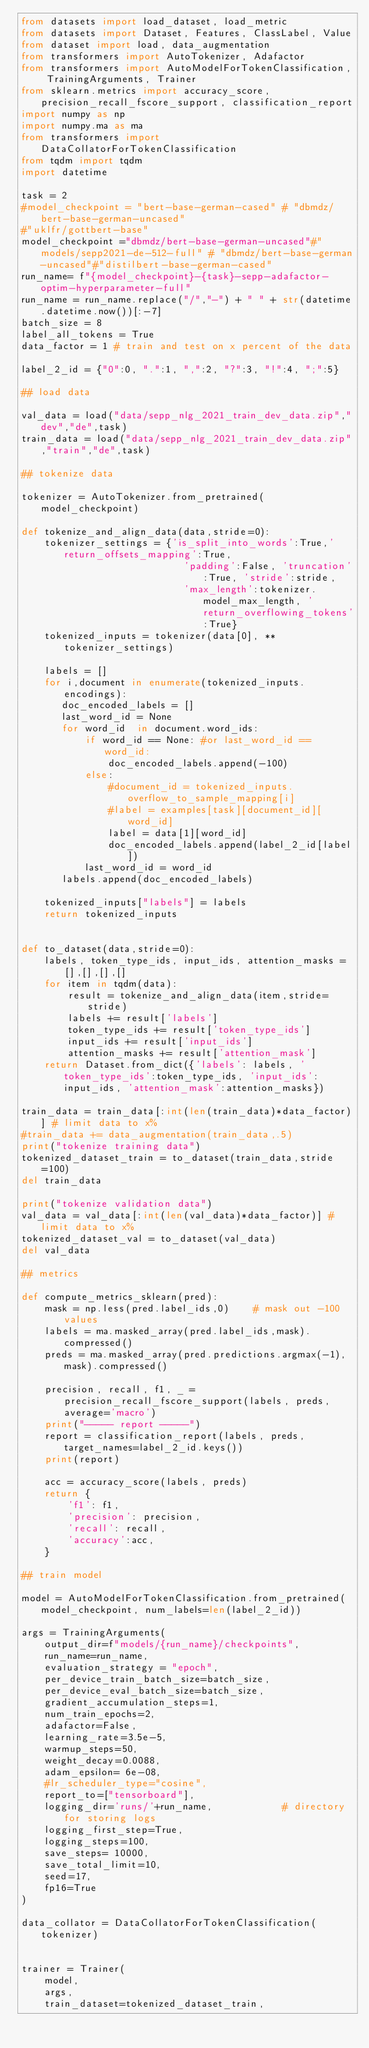<code> <loc_0><loc_0><loc_500><loc_500><_Python_>from datasets import load_dataset, load_metric
from datasets import Dataset, Features, ClassLabel, Value
from dataset import load, data_augmentation
from transformers import AutoTokenizer, Adafactor
from transformers import AutoModelForTokenClassification, TrainingArguments, Trainer
from sklearn.metrics import accuracy_score, precision_recall_fscore_support, classification_report
import numpy as np
import numpy.ma as ma
from transformers import DataCollatorForTokenClassification
from tqdm import tqdm
import datetime

task = 2 
#model_checkpoint = "bert-base-german-cased" # "dbmdz/bert-base-german-uncased"
#"uklfr/gottbert-base"
model_checkpoint ="dbmdz/bert-base-german-uncased"#"models/sepp2021-de-512-full" # "dbmdz/bert-base-german-uncased"#"distilbert-base-german-cased"
run_name= f"{model_checkpoint}-{task}-sepp-adafactor-optim-hyperparameter-full"
run_name = run_name.replace("/","-") + " " + str(datetime.datetime.now())[:-7]
batch_size = 8
label_all_tokens = True
data_factor = 1 # train and test on x percent of the data

label_2_id = {"0":0, ".":1, ",":2, "?":3, "!":4, ";":5}

## load data

val_data = load("data/sepp_nlg_2021_train_dev_data.zip","dev","de",task)
train_data = load("data/sepp_nlg_2021_train_dev_data.zip","train","de",task)

## tokenize data
    
tokenizer = AutoTokenizer.from_pretrained(model_checkpoint)

def tokenize_and_align_data(data,stride=0):
    tokenizer_settings = {'is_split_into_words':True,'return_offsets_mapping':True, 
                            'padding':False, 'truncation':True, 'stride':stride, 
                            'max_length':tokenizer.model_max_length, 'return_overflowing_tokens':True}
    tokenized_inputs = tokenizer(data[0], **tokenizer_settings)

    labels = []
    for i,document in enumerate(tokenized_inputs.encodings):
       doc_encoded_labels = []
       last_word_id = None
       for word_id  in document.word_ids:            
           if word_id == None: #or last_word_id == word_id:
               doc_encoded_labels.append(-100)        
           else:
               #document_id = tokenized_inputs.overflow_to_sample_mapping[i]
               #label = examples[task][document_id][word_id]
               label = data[1][word_id]
               doc_encoded_labels.append(label_2_id[label])
           last_word_id = word_id
       labels.append(doc_encoded_labels)
    
    tokenized_inputs["labels"] = labels    
    return tokenized_inputs


def to_dataset(data,stride=0):
    labels, token_type_ids, input_ids, attention_masks = [],[],[],[]
    for item in tqdm(data):
        result = tokenize_and_align_data(item,stride=stride)        
        labels += result['labels']
        token_type_ids += result['token_type_ids']
        input_ids += result['input_ids']
        attention_masks += result['attention_mask']
    return Dataset.from_dict({'labels': labels, 'token_type_ids':token_type_ids, 'input_ids':input_ids, 'attention_mask':attention_masks})

train_data = train_data[:int(len(train_data)*data_factor)] # limit data to x%
#train_data += data_augmentation(train_data,.5)
print("tokenize training data")
tokenized_dataset_train = to_dataset(train_data,stride=100)
del train_data

print("tokenize validation data")
val_data = val_data[:int(len(val_data)*data_factor)] # limit data to x%
tokenized_dataset_val = to_dataset(val_data)
del val_data

## metrics 

def compute_metrics_sklearn(pred):    
    mask = np.less(pred.label_ids,0)    # mask out -100 values
    labels = ma.masked_array(pred.label_ids,mask).compressed() 
    preds = ma.masked_array(pred.predictions.argmax(-1),mask).compressed() 

    precision, recall, f1, _ = precision_recall_fscore_support(labels, preds, average='macro')  
    print("----- report -----")
    report = classification_report(labels, preds,target_names=label_2_id.keys())
    print(report)
 
    acc = accuracy_score(labels, preds)    
    return {     
        'f1': f1,
        'precision': precision,
        'recall': recall,
        'accuracy':acc,        
    }

## train model

model = AutoModelForTokenClassification.from_pretrained(model_checkpoint, num_labels=len(label_2_id))

args = TrainingArguments(
    output_dir=f"models/{run_name}/checkpoints",
    run_name=run_name,    
    evaluation_strategy = "epoch",
    per_device_train_batch_size=batch_size,
    per_device_eval_batch_size=batch_size,
    gradient_accumulation_steps=1,
    num_train_epochs=2,
    adafactor=False, 
    learning_rate=3.5e-5,    
    warmup_steps=50,    
    weight_decay=0.0088,
    adam_epsilon= 6e-08,
    #lr_scheduler_type="cosine",
    report_to=["tensorboard"],
    logging_dir='runs/'+run_name,            # directory for storing logs
    logging_first_step=True,
    logging_steps=100,
    save_steps= 10000,
    save_total_limit=10,
    seed=17, 
    fp16=True   
)

data_collator = DataCollatorForTokenClassification(tokenizer)


trainer = Trainer(
    model,
    args,    
    train_dataset=tokenized_dataset_train,</code> 